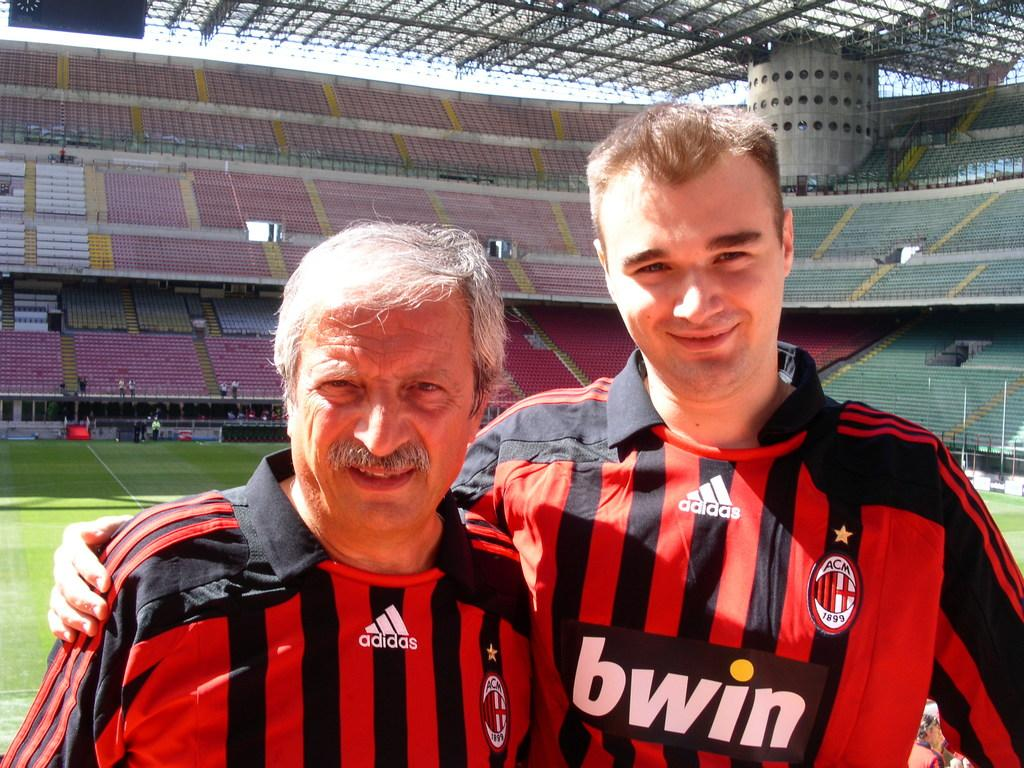<image>
Summarize the visual content of the image. Two men, wearing Adidas-brand jerseys, pose for a picture. 